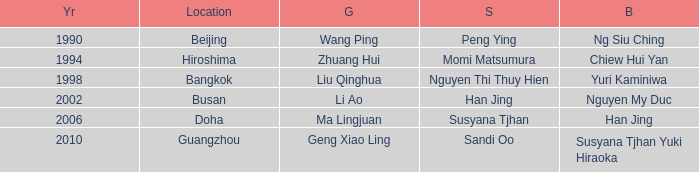What's the lowest Year with the Location of Bangkok? 1998.0. 